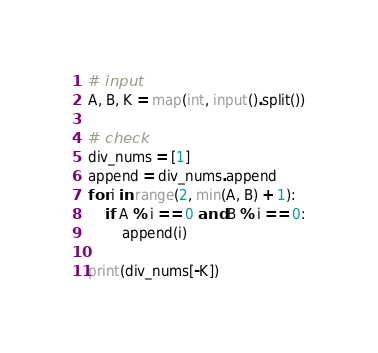Convert code to text. <code><loc_0><loc_0><loc_500><loc_500><_Python_># input
A, B, K = map(int, input().split())

# check
div_nums = [1]
append = div_nums.append
for i in range(2, min(A, B) + 1):
    if A % i == 0 and B % i == 0:
        append(i)

print(div_nums[-K])</code> 